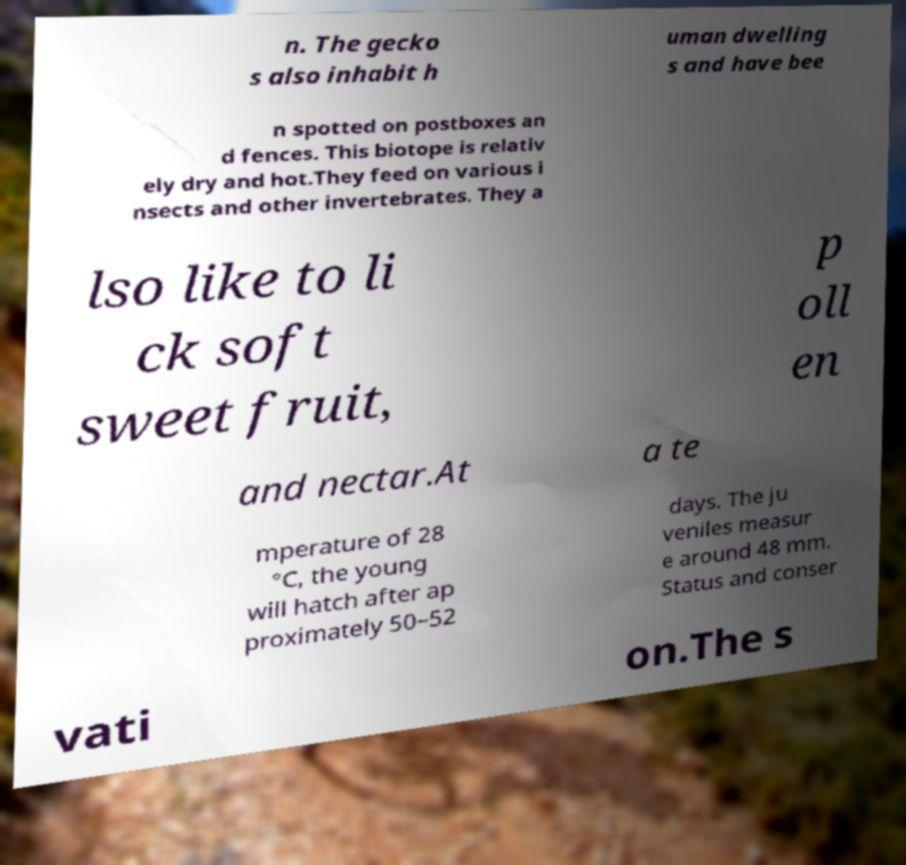What messages or text are displayed in this image? I need them in a readable, typed format. n. The gecko s also inhabit h uman dwelling s and have bee n spotted on postboxes an d fences. This biotope is relativ ely dry and hot.They feed on various i nsects and other invertebrates. They a lso like to li ck soft sweet fruit, p oll en and nectar.At a te mperature of 28 °C, the young will hatch after ap proximately 50–52 days. The ju veniles measur e around 48 mm. Status and conser vati on.The s 